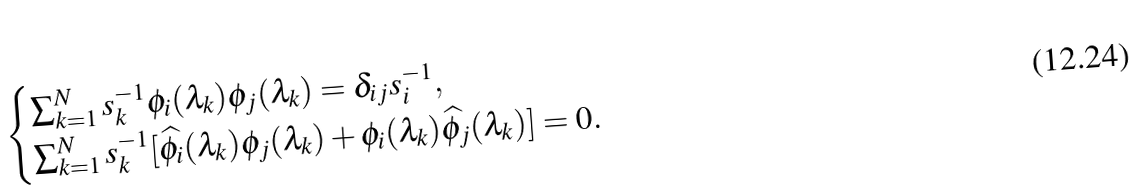Convert formula to latex. <formula><loc_0><loc_0><loc_500><loc_500>\begin{cases} \sum _ { k = 1 } ^ { N } s _ { k } ^ { - 1 } \phi _ { i } ( \lambda _ { k } ) \phi _ { j } ( \lambda _ { k } ) = \delta _ { i j } s _ { i } ^ { - 1 } , \\ \sum _ { k = 1 } ^ { N } s _ { k } ^ { - 1 } [ \widehat { \phi } _ { i } ( \lambda _ { k } ) \phi _ { j } ( \lambda _ { k } ) + \phi _ { i } ( \lambda _ { k } ) \widehat { \phi } _ { j } ( \lambda _ { k } ) ] = 0 . \end{cases}</formula> 